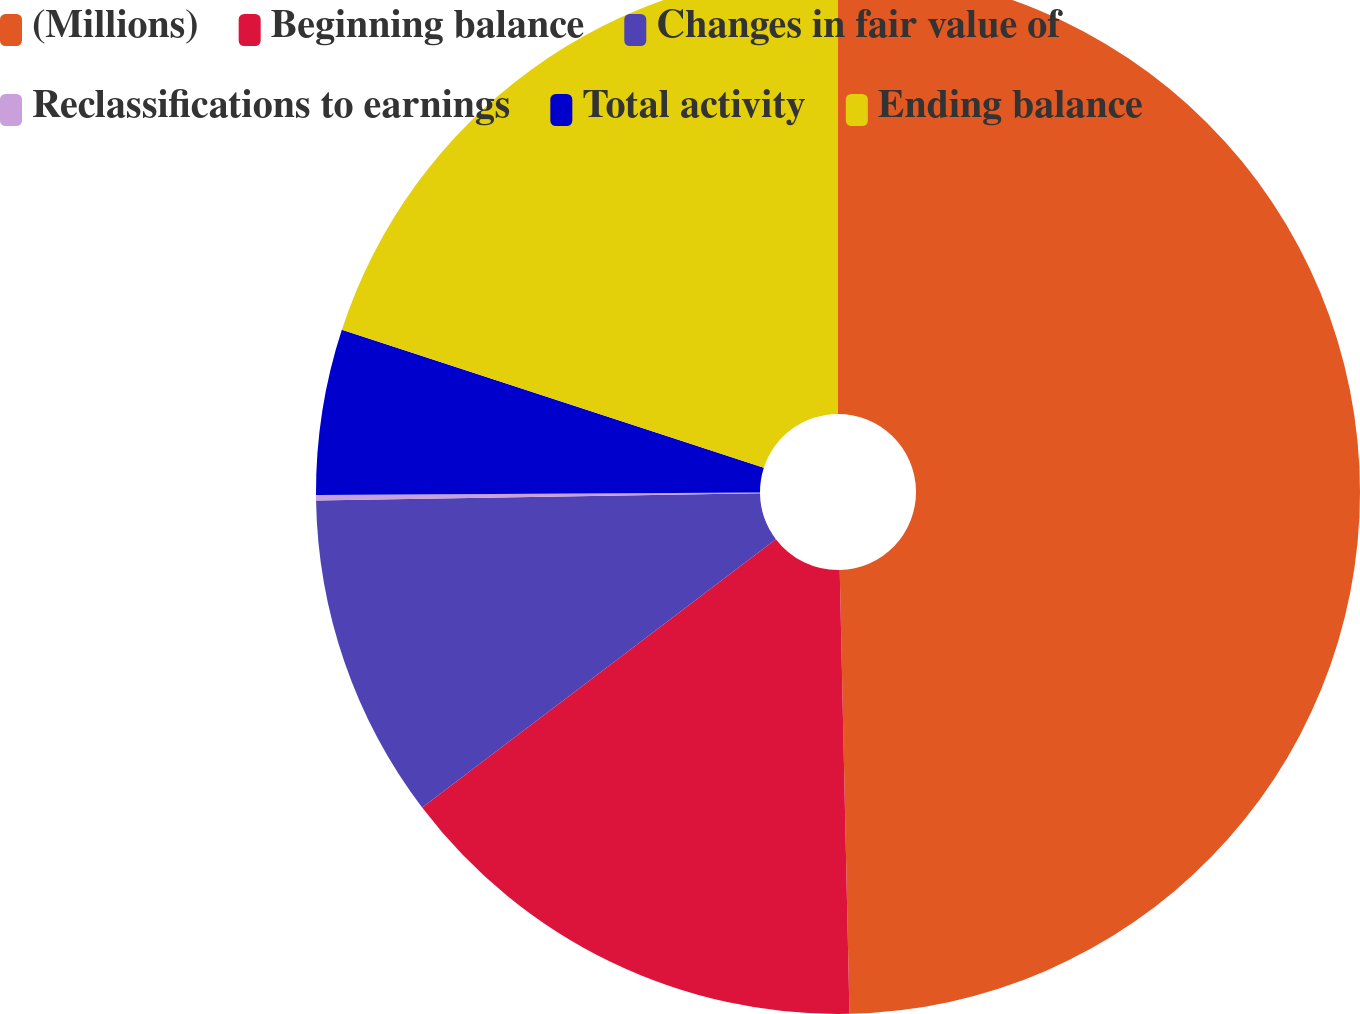Convert chart. <chart><loc_0><loc_0><loc_500><loc_500><pie_chart><fcel>(Millions)<fcel>Beginning balance<fcel>Changes in fair value of<fcel>Reclassifications to earnings<fcel>Total activity<fcel>Ending balance<nl><fcel>49.65%<fcel>15.02%<fcel>10.07%<fcel>0.17%<fcel>5.12%<fcel>19.97%<nl></chart> 